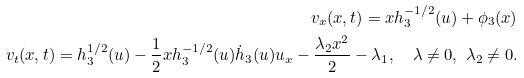Convert formula to latex. <formula><loc_0><loc_0><loc_500><loc_500>v _ { x } ( x , t ) = x h _ { 3 } ^ { - 1 / 2 } ( u ) + \phi _ { 3 } ( x ) \\ v _ { t } ( x , t ) = h _ { 3 } ^ { 1 / 2 } ( u ) - \frac { 1 } { 2 } x h _ { 3 } ^ { - 1 / 2 } ( u ) \dot { h } _ { 3 } ( u ) u _ { x } - \frac { \lambda _ { 2 } x ^ { 2 } } { 2 } - \lambda _ { 1 } , \quad \lambda \neq 0 , \ \lambda _ { 2 } \neq 0 .</formula> 